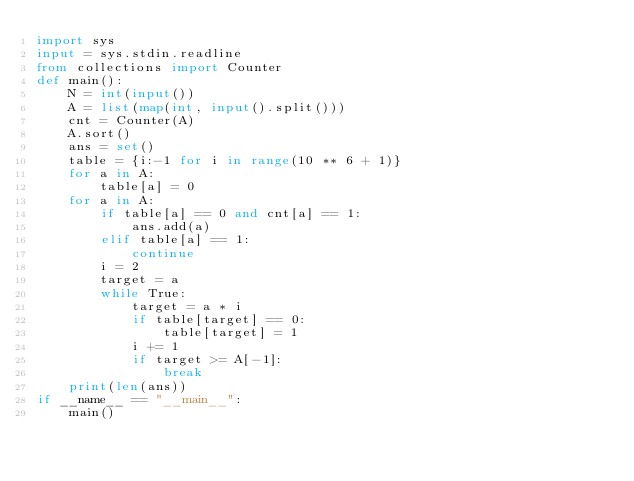<code> <loc_0><loc_0><loc_500><loc_500><_Python_>import sys
input = sys.stdin.readline
from collections import Counter
def main():
    N = int(input())
    A = list(map(int, input().split()))
    cnt = Counter(A)
    A.sort()
    ans = set()
    table = {i:-1 for i in range(10 ** 6 + 1)}
    for a in A:
        table[a] = 0
    for a in A:
        if table[a] == 0 and cnt[a] == 1:
            ans.add(a)
        elif table[a] == 1:
            continue
        i = 2
        target = a
        while True:
            target = a * i
            if table[target] == 0:
                table[target] = 1
            i += 1
            if target >= A[-1]:
                break
    print(len(ans))
if __name__ == "__main__":
    main()</code> 